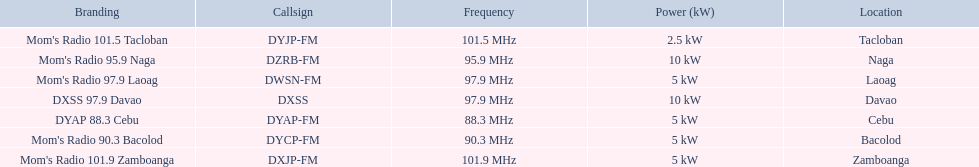What brandings have a power of 5 kw? Mom's Radio 97.9 Laoag, Mom's Radio 90.3 Bacolod, DYAP 88.3 Cebu, Mom's Radio 101.9 Zamboanga. Which of these has a call-sign beginning with dy? Mom's Radio 90.3 Bacolod, DYAP 88.3 Cebu. Which of those uses the lowest frequency? DYAP 88.3 Cebu. 